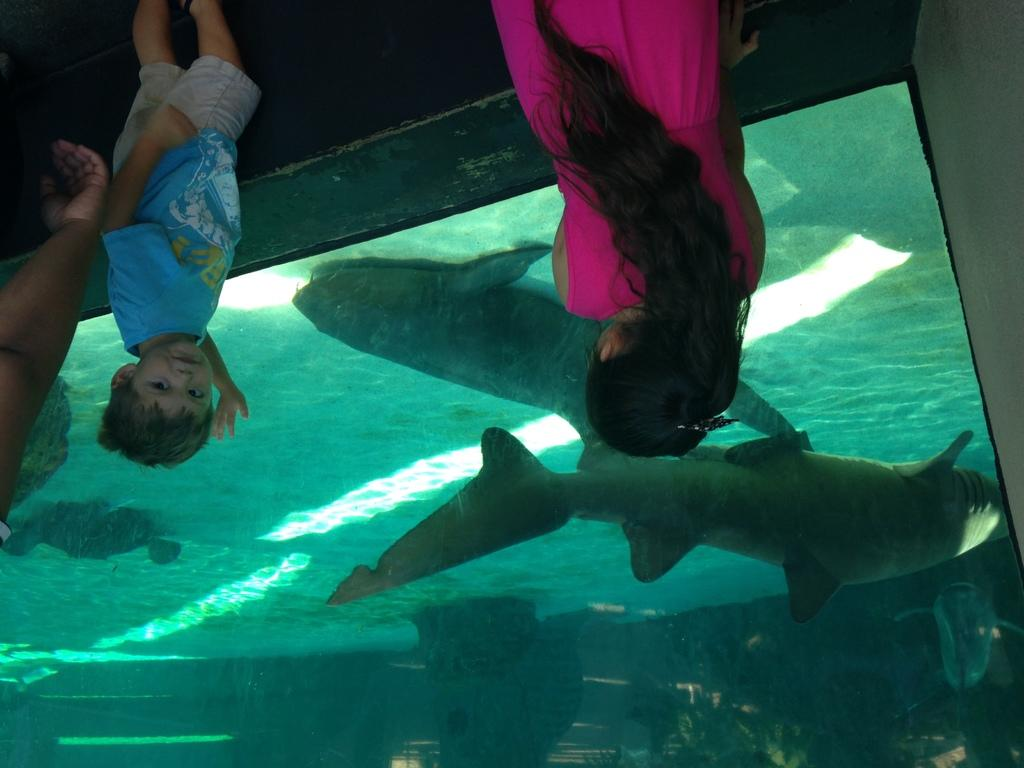How many kids are in the image? There are two kids in the image. What colors are the dresses worn by the kids? One kid is wearing a pink dress, and the other kid is wearing a blue dress. What can be seen near the kids? The kids are standing near a fish aquarium. What is inside the fish aquarium? There are fishes in the fish aquarium. Can you tell me how many loaves of bread are on the table in the image? There is no table or loaves of bread present in the image. What type of nut is being cracked by the kids in the image? There is no nut or cracking activity depicted in the image. 